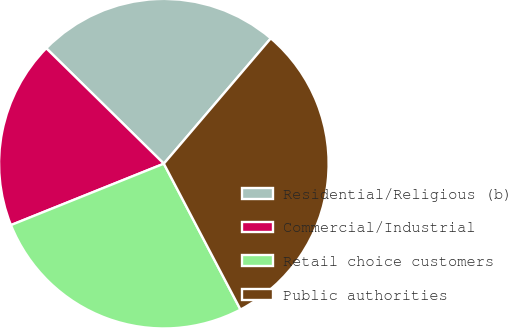Convert chart to OTSL. <chart><loc_0><loc_0><loc_500><loc_500><pie_chart><fcel>Residential/Religious (b)<fcel>Commercial/Industrial<fcel>Retail choice customers<fcel>Public authorities<nl><fcel>23.89%<fcel>18.43%<fcel>26.62%<fcel>31.06%<nl></chart> 